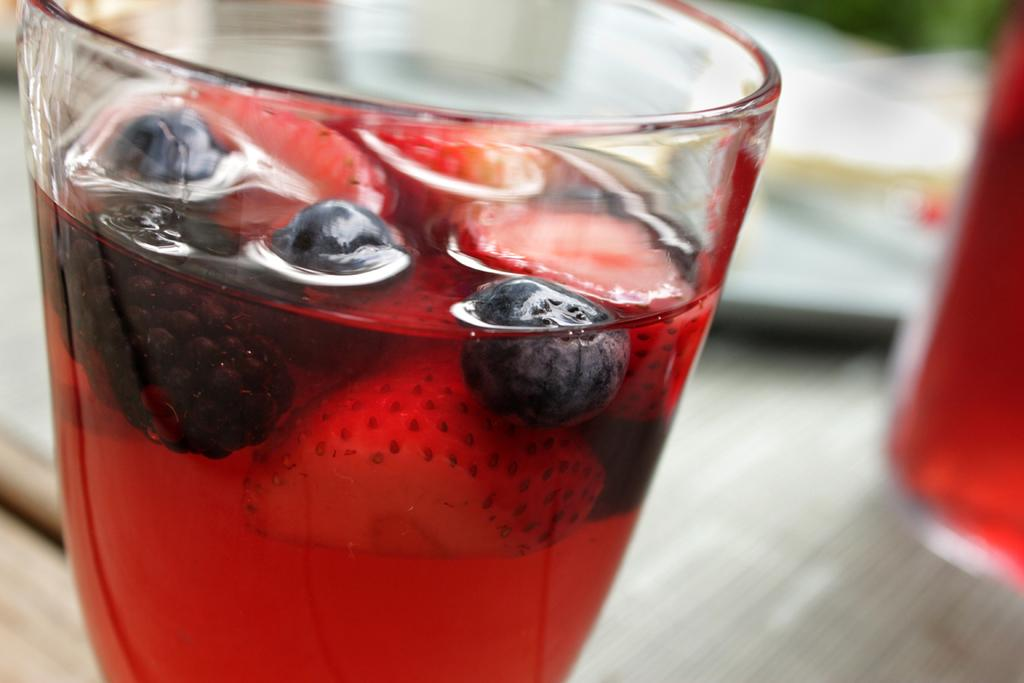What is inside the glass that is visible in the image? There is a glass containing liquid and fruit pieces in the image. What types of fruit pieces can be seen in the glass? The fruit pieces include strawberries, raspberries, and blueberries. How many glasses are visible in the image? There is another glass in the image. What other object can be seen in the image besides the glasses? There is a plate in the image. What advice is given by the wine in the image? There is no wine present in the image, so no advice can be given by it. 